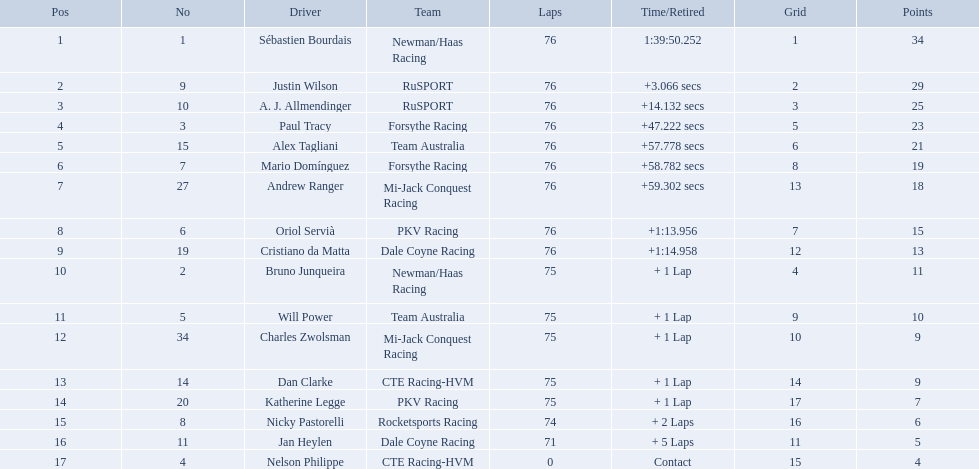What was alex taglini's final score in the tecate grand prix? 21. What was paul tracy's final score in the tecate grand prix? 23. Which driver finished first? Paul Tracy. What racing drivers competed in the 2006 tecate grand prix of monterrey? Sébastien Bourdais, Justin Wilson, A. J. Allmendinger, Paul Tracy, Alex Tagliani, Mario Domínguez, Andrew Ranger, Oriol Servià, Cristiano da Matta, Bruno Junqueira, Will Power, Charles Zwolsman, Dan Clarke, Katherine Legge, Nicky Pastorelli, Jan Heylen, Nelson Philippe. Which of them obtained the same score as another driver? Charles Zwolsman, Dan Clarke. Who matched the points of charles zwolsman? Dan Clarke. Who raced in the 2006 tecate grand prix of monterrey? Sébastien Bourdais, Justin Wilson, A. J. Allmendinger, Paul Tracy, Alex Tagliani, Mario Domínguez, Andrew Ranger, Oriol Servià, Cristiano da Matta, Bruno Junqueira, Will Power, Charles Zwolsman, Dan Clarke, Katherine Legge, Nicky Pastorelli, Jan Heylen, Nelson Philippe. And what were their concluding spots? 1, 2, 3, 4, 5, 6, 7, 8, 9, 10, 11, 12, 13, 14, 15, 16, 17. Who did alex tagliani end up right behind? Paul Tracy. What was the ultimate score of alex taglini in the tecate grand prix? 21. What was the ultimate score of paul tracy in the tecate grand prix? 23. Which competitor came in first? Paul Tracy. Is there a driver called charles zwolsman? Charles Zwolsman. How many points did he obtain? 9. Were there any other participants with the same number of points? 9. To whom did that entry belong? Dan Clarke. Parse the full table. {'header': ['Pos', 'No', 'Driver', 'Team', 'Laps', 'Time/Retired', 'Grid', 'Points'], 'rows': [['1', '1', 'Sébastien Bourdais', 'Newman/Haas Racing', '76', '1:39:50.252', '1', '34'], ['2', '9', 'Justin Wilson', 'RuSPORT', '76', '+3.066 secs', '2', '29'], ['3', '10', 'A. J. Allmendinger', 'RuSPORT', '76', '+14.132 secs', '3', '25'], ['4', '3', 'Paul Tracy', 'Forsythe Racing', '76', '+47.222 secs', '5', '23'], ['5', '15', 'Alex Tagliani', 'Team Australia', '76', '+57.778 secs', '6', '21'], ['6', '7', 'Mario Domínguez', 'Forsythe Racing', '76', '+58.782 secs', '8', '19'], ['7', '27', 'Andrew Ranger', 'Mi-Jack Conquest Racing', '76', '+59.302 secs', '13', '18'], ['8', '6', 'Oriol Servià', 'PKV Racing', '76', '+1:13.956', '7', '15'], ['9', '19', 'Cristiano da Matta', 'Dale Coyne Racing', '76', '+1:14.958', '12', '13'], ['10', '2', 'Bruno Junqueira', 'Newman/Haas Racing', '75', '+ 1 Lap', '4', '11'], ['11', '5', 'Will Power', 'Team Australia', '75', '+ 1 Lap', '9', '10'], ['12', '34', 'Charles Zwolsman', 'Mi-Jack Conquest Racing', '75', '+ 1 Lap', '10', '9'], ['13', '14', 'Dan Clarke', 'CTE Racing-HVM', '75', '+ 1 Lap', '14', '9'], ['14', '20', 'Katherine Legge', 'PKV Racing', '75', '+ 1 Lap', '17', '7'], ['15', '8', 'Nicky Pastorelli', 'Rocketsports Racing', '74', '+ 2 Laps', '16', '6'], ['16', '11', 'Jan Heylen', 'Dale Coyne Racing', '71', '+ 5 Laps', '11', '5'], ['17', '4', 'Nelson Philippe', 'CTE Racing-HVM', '0', 'Contact', '15', '4']]} Who were the drivers in the 2006 tecate grand prix of monterrey? Sébastien Bourdais, Justin Wilson, A. J. Allmendinger, Paul Tracy, Alex Tagliani, Mario Domínguez, Andrew Ranger, Oriol Servià, Cristiano da Matta, Bruno Junqueira, Will Power, Charles Zwolsman, Dan Clarke, Katherine Legge, Nicky Pastorelli, Jan Heylen, Nelson Philippe. Which drivers had an equal number of points? Charles Zwolsman, Dan Clarke. Who had the same points as charles zwolsman? Dan Clarke. What was the total number of points accumulated by charles zwolsman? 9. Can you also name others who obtained 9 points? Dan Clarke. Can you give me this table in json format? {'header': ['Pos', 'No', 'Driver', 'Team', 'Laps', 'Time/Retired', 'Grid', 'Points'], 'rows': [['1', '1', 'Sébastien Bourdais', 'Newman/Haas Racing', '76', '1:39:50.252', '1', '34'], ['2', '9', 'Justin Wilson', 'RuSPORT', '76', '+3.066 secs', '2', '29'], ['3', '10', 'A. J. Allmendinger', 'RuSPORT', '76', '+14.132 secs', '3', '25'], ['4', '3', 'Paul Tracy', 'Forsythe Racing', '76', '+47.222 secs', '5', '23'], ['5', '15', 'Alex Tagliani', 'Team Australia', '76', '+57.778 secs', '6', '21'], ['6', '7', 'Mario Domínguez', 'Forsythe Racing', '76', '+58.782 secs', '8', '19'], ['7', '27', 'Andrew Ranger', 'Mi-Jack Conquest Racing', '76', '+59.302 secs', '13', '18'], ['8', '6', 'Oriol Servià', 'PKV Racing', '76', '+1:13.956', '7', '15'], ['9', '19', 'Cristiano da Matta', 'Dale Coyne Racing', '76', '+1:14.958', '12', '13'], ['10', '2', 'Bruno Junqueira', 'Newman/Haas Racing', '75', '+ 1 Lap', '4', '11'], ['11', '5', 'Will Power', 'Team Australia', '75', '+ 1 Lap', '9', '10'], ['12', '34', 'Charles Zwolsman', 'Mi-Jack Conquest Racing', '75', '+ 1 Lap', '10', '9'], ['13', '14', 'Dan Clarke', 'CTE Racing-HVM', '75', '+ 1 Lap', '14', '9'], ['14', '20', 'Katherine Legge', 'PKV Racing', '75', '+ 1 Lap', '17', '7'], ['15', '8', 'Nicky Pastorelli', 'Rocketsports Racing', '74', '+ 2 Laps', '16', '6'], ['16', '11', 'Jan Heylen', 'Dale Coyne Racing', '71', '+ 5 Laps', '11', '5'], ['17', '4', 'Nelson Philippe', 'CTE Racing-HVM', '0', 'Contact', '15', '4']]} What was the last score for alex taglini in the tecate grand prix? 21. What was paul tracy's concluding score in the race? 23. Which competitor secured the first position? Paul Tracy. Who were the drivers that completed all 76 laps? Sébastien Bourdais, Justin Wilson, A. J. Allmendinger, Paul Tracy, Alex Tagliani, Mario Domínguez, Andrew Ranger, Oriol Servià, Cristiano da Matta. From this group, who were the ones that finished less than a minute behind the winner? Paul Tracy, Alex Tagliani, Mario Domínguez, Andrew Ranger. Out of these, who were within 50 seconds behind the first-place finisher? Justin Wilson, A. J. Allmendinger, Paul Tracy. Among these three drivers, who ended up last? Paul Tracy. 